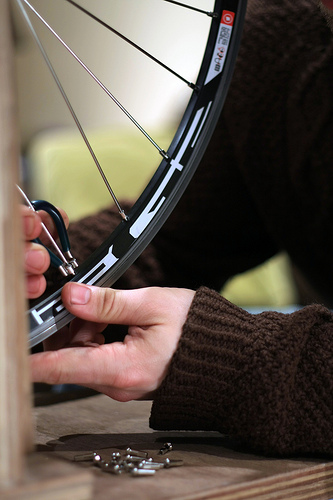<image>
Can you confirm if the sleeve is on the body part? Yes. Looking at the image, I can see the sleeve is positioned on top of the body part, with the body part providing support. Where is the spoke in relation to the rim? Is it in the rim? Yes. The spoke is contained within or inside the rim, showing a containment relationship. 